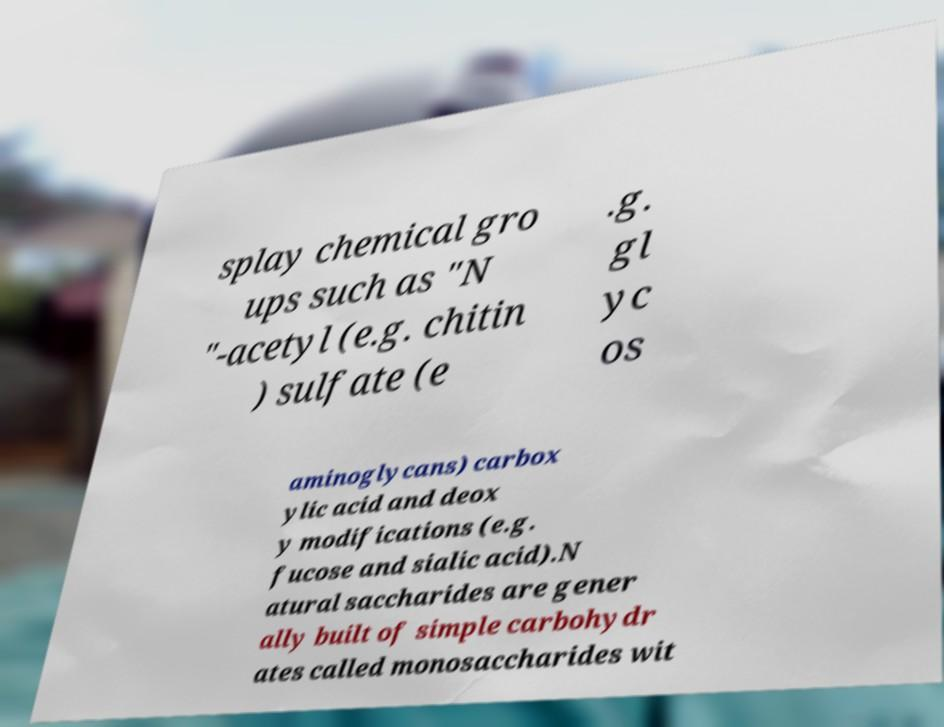Could you assist in decoding the text presented in this image and type it out clearly? splay chemical gro ups such as "N "-acetyl (e.g. chitin ) sulfate (e .g. gl yc os aminoglycans) carbox ylic acid and deox y modifications (e.g. fucose and sialic acid).N atural saccharides are gener ally built of simple carbohydr ates called monosaccharides wit 